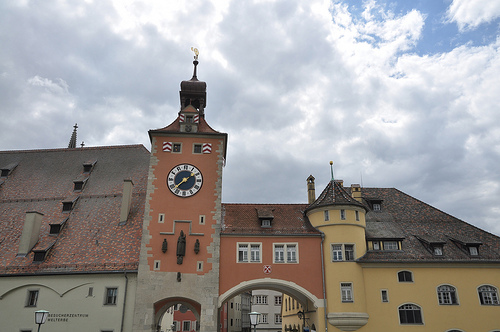Please provide a short description for this region: [0.51, 0.39, 0.62, 0.52]. This region of the image depicts a cloud. 